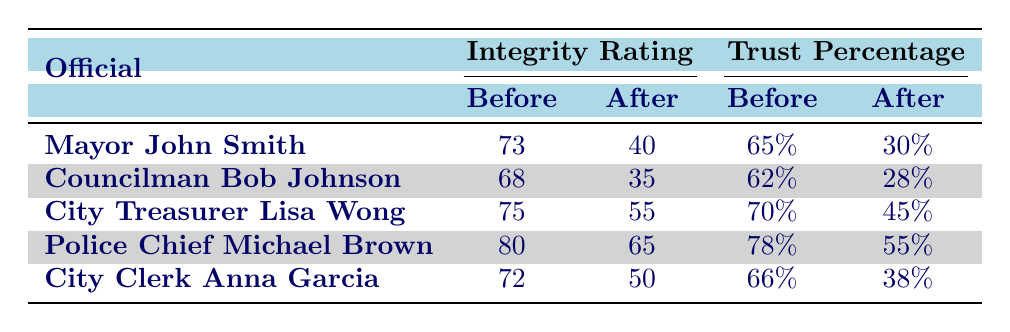What was the integrity rating of Mayor John Smith before the disclosure? The table lists the integrity rating of Mayor John Smith as 73 before the disclosure.
Answer: 73 What is the percent trust in City Treasurer Lisa Wong after the disclosure? The table shows that the percent trust in City Treasurer Lisa Wong after the disclosure is 45%.
Answer: 45% Which city official had the highest integrity rating after their disclosure? By examining the integrity ratings after the disclosures, Police Chief Michael Brown had the highest rating of 65.
Answer: 65 What is the percentage decrease in trust for Councilman Bob Johnson after the disclosure? The trust percentage for Councilman Bob Johnson decreased from 62% to 28%. The difference is 62 - 28 = 34, thus the percentage decrease is 34.
Answer: 34 Was the integrity rating for City Clerk Anna Garcia higher before or after the disclosure? Looking at the integrity rating for City Clerk Anna Garcia, it was 72 before the disclosure and 50 after the disclosure, indicating it was higher before.
Answer: Before What is the average integrity rating before the disclosures for all city officials? To find the average integrity rating before the disclosures, add the values: (73 + 68 + 75 + 80 + 72) = 368. There are 5 officials, so the average is 368 / 5 = 73.6.
Answer: 73.6 Did any city official see an increase in their integrity rating after the disclosure? Evaluating the integrity ratings after disclosures shows all officials had lower ratings, with the highest prior rating being 80 and the highest after being 65, thus no officials saw an increase.
Answer: No What is the overall change in integrity rating for City Treasurer Lisa Wong? The integrity rating for City Treasurer Lisa Wong changed from 75 before the disclosure to 55 after it, so the change is 75 - 55 = 20, indicating a decrease.
Answer: 20 Which official had the least percent trust after the disclosure, and what was the percentage? By looking at the trust percentages after the disclosure, Councilman Bob Johnson had the least trust at 28%.
Answer: Councilman Bob Johnson, 28% 